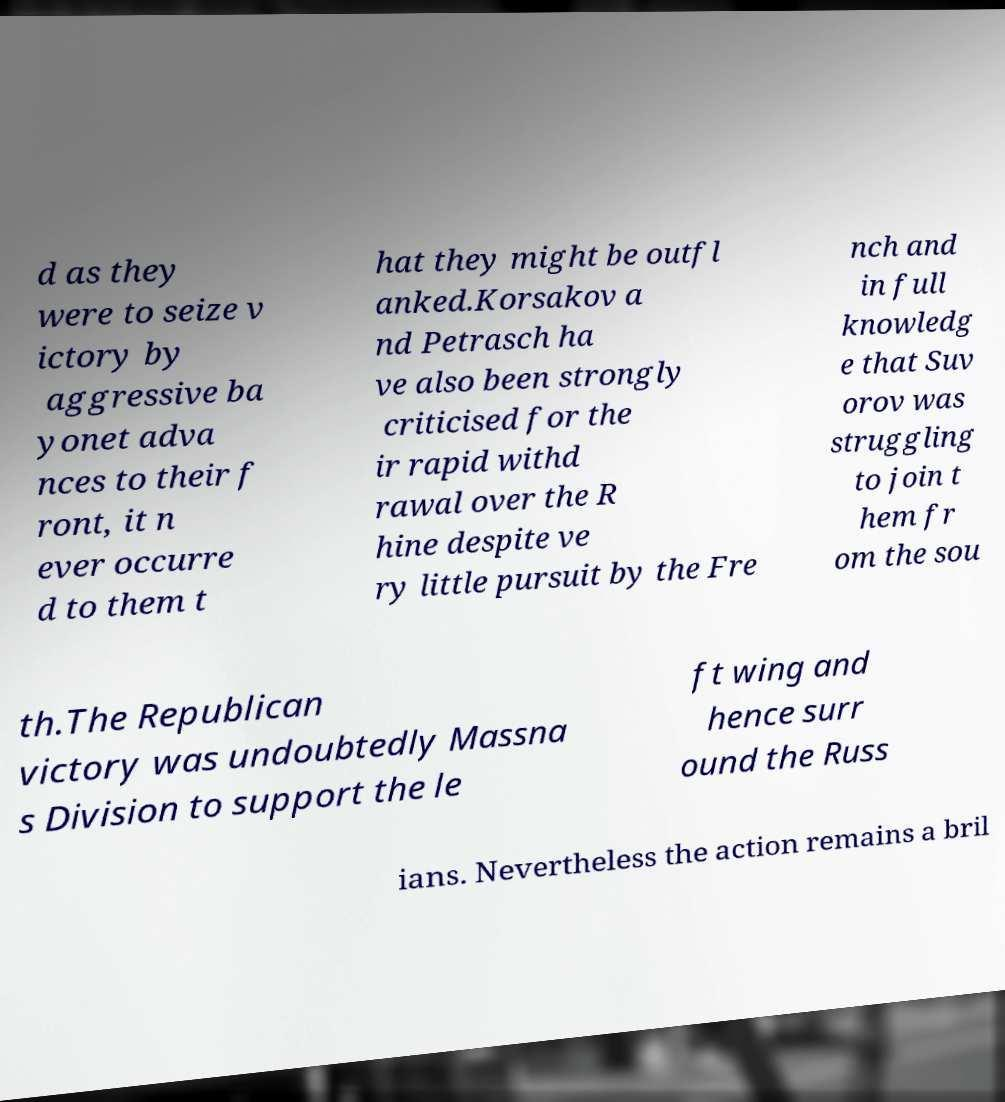What messages or text are displayed in this image? I need them in a readable, typed format. d as they were to seize v ictory by aggressive ba yonet adva nces to their f ront, it n ever occurre d to them t hat they might be outfl anked.Korsakov a nd Petrasch ha ve also been strongly criticised for the ir rapid withd rawal over the R hine despite ve ry little pursuit by the Fre nch and in full knowledg e that Suv orov was struggling to join t hem fr om the sou th.The Republican victory was undoubtedly Massna s Division to support the le ft wing and hence surr ound the Russ ians. Nevertheless the action remains a bril 